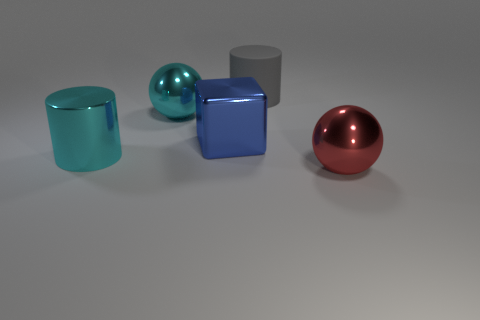Add 4 large blue things. How many objects exist? 9 Subtract all balls. How many objects are left? 3 Subtract 0 brown balls. How many objects are left? 5 Subtract all red blocks. Subtract all blue cylinders. How many blocks are left? 1 Subtract all purple metal objects. Subtract all red metallic objects. How many objects are left? 4 Add 4 big red metallic balls. How many big red metallic balls are left? 5 Add 1 big cyan metal balls. How many big cyan metal balls exist? 2 